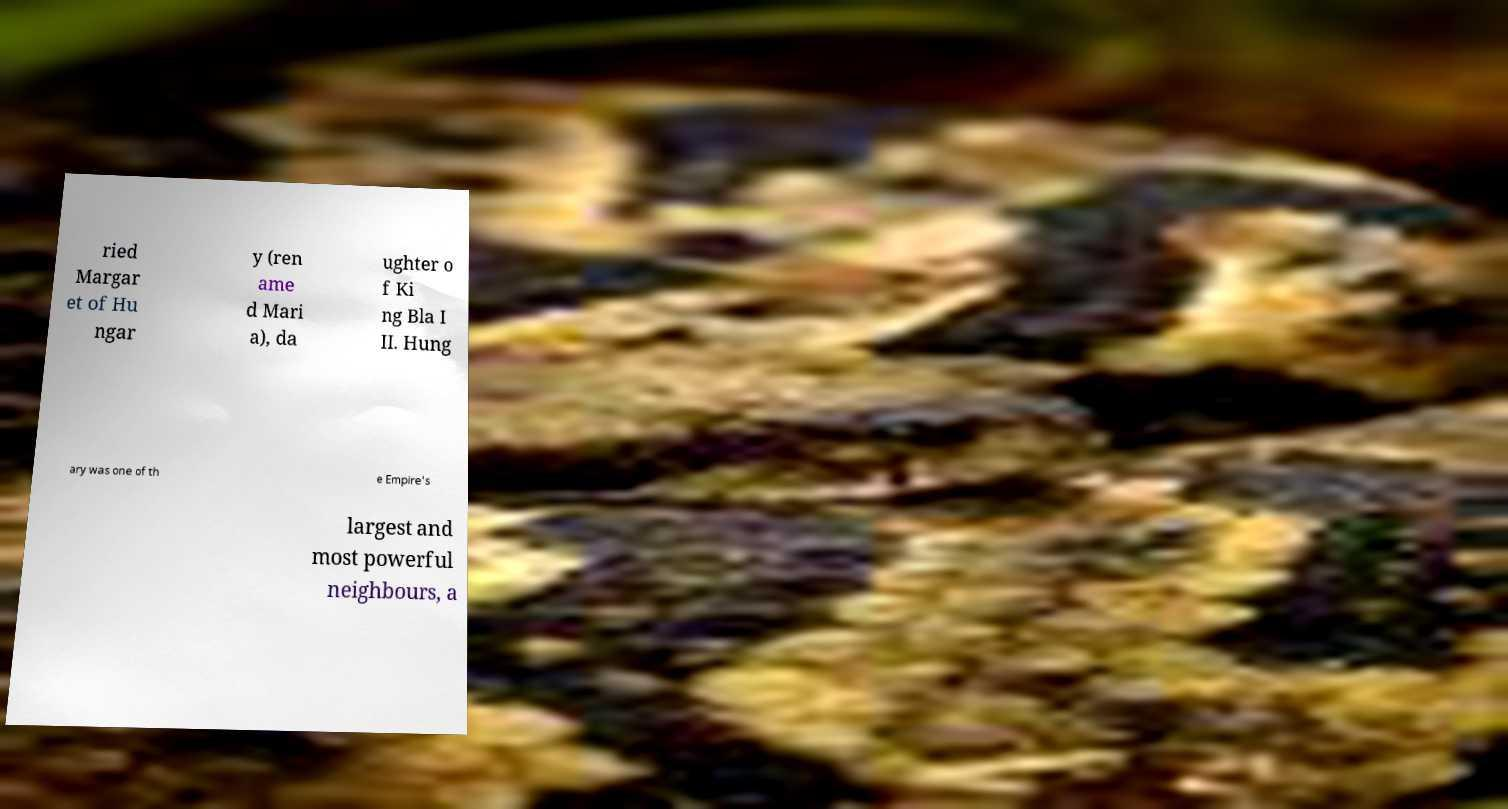Please read and relay the text visible in this image. What does it say? ried Margar et of Hu ngar y (ren ame d Mari a), da ughter o f Ki ng Bla I II. Hung ary was one of th e Empire's largest and most powerful neighbours, a 